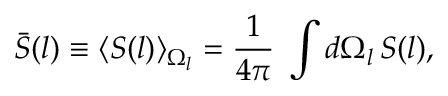<formula> <loc_0><loc_0><loc_500><loc_500>\bar { S } ( l ) \equiv \langle S ( l ) \rangle _ { \Omega _ { l } } = \frac { 1 } { 4 \pi } \, \int d \Omega _ { l } \, S ( l ) ,</formula> 